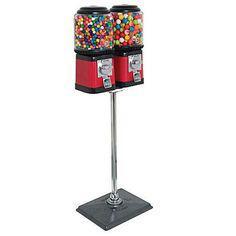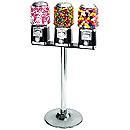The first image is the image on the left, the second image is the image on the right. Examine the images to the left and right. Is the description "An image shows just one vending machine, which has a trio of dispensers combined into one rectangular box shape." accurate? Answer yes or no. No. 